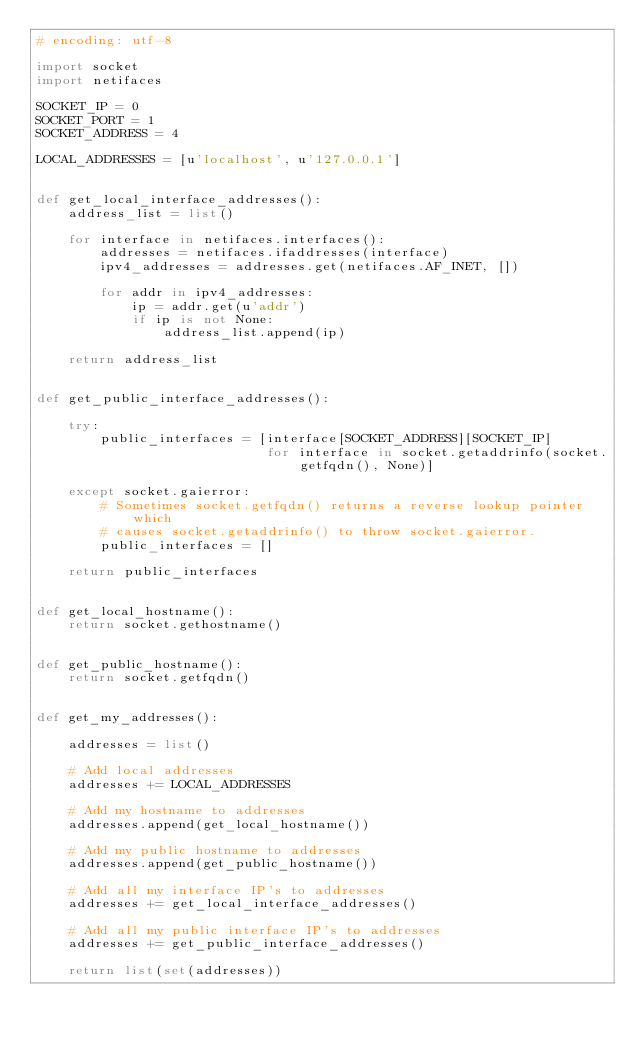<code> <loc_0><loc_0><loc_500><loc_500><_Python_># encoding: utf-8

import socket
import netifaces

SOCKET_IP = 0
SOCKET_PORT = 1
SOCKET_ADDRESS = 4

LOCAL_ADDRESSES = [u'localhost', u'127.0.0.1']


def get_local_interface_addresses():
    address_list = list()

    for interface in netifaces.interfaces():
        addresses = netifaces.ifaddresses(interface)
        ipv4_addresses = addresses.get(netifaces.AF_INET, [])

        for addr in ipv4_addresses:
            ip = addr.get(u'addr')
            if ip is not None:
                address_list.append(ip)

    return address_list


def get_public_interface_addresses():

    try:
        public_interfaces = [interface[SOCKET_ADDRESS][SOCKET_IP]
                             for interface in socket.getaddrinfo(socket.getfqdn(), None)]

    except socket.gaierror:
        # Sometimes socket.getfqdn() returns a reverse lookup pointer which
        # causes socket.getaddrinfo() to throw socket.gaierror.
        public_interfaces = []

    return public_interfaces


def get_local_hostname():
    return socket.gethostname()


def get_public_hostname():
    return socket.getfqdn()


def get_my_addresses():

    addresses = list()

    # Add local addresses
    addresses += LOCAL_ADDRESSES

    # Add my hostname to addresses
    addresses.append(get_local_hostname())

    # Add my public hostname to addresses
    addresses.append(get_public_hostname())

    # Add all my interface IP's to addresses
    addresses += get_local_interface_addresses()

    # Add all my public interface IP's to addresses
    addresses += get_public_interface_addresses()

    return list(set(addresses))
</code> 